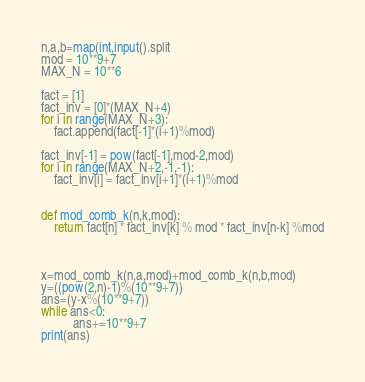Convert code to text. <code><loc_0><loc_0><loc_500><loc_500><_Python_>
n,a,b=map(int,input().split
mod = 10**9+7
MAX_N = 10**6

fact = [1]
fact_inv = [0]*(MAX_N+4)
for i in range(MAX_N+3):
    fact.append(fact[-1]*(i+1)%mod)

fact_inv[-1] = pow(fact[-1],mod-2,mod)
for i in range(MAX_N+2,-1,-1):
    fact_inv[i] = fact_inv[i+1]*(i+1)%mod


def mod_comb_k(n,k,mod):
    return fact[n] * fact_inv[k] % mod * fact_inv[n-k] %mod



x=mod_comb_k(n,a,mod)+mod_comb_k(n,b,mod)
y=((pow(2,n)-1)%(10**9+7))
ans=(y-x%(10**9+7))
while ans<0:
          ans+=10**9+7
print(ans)

</code> 